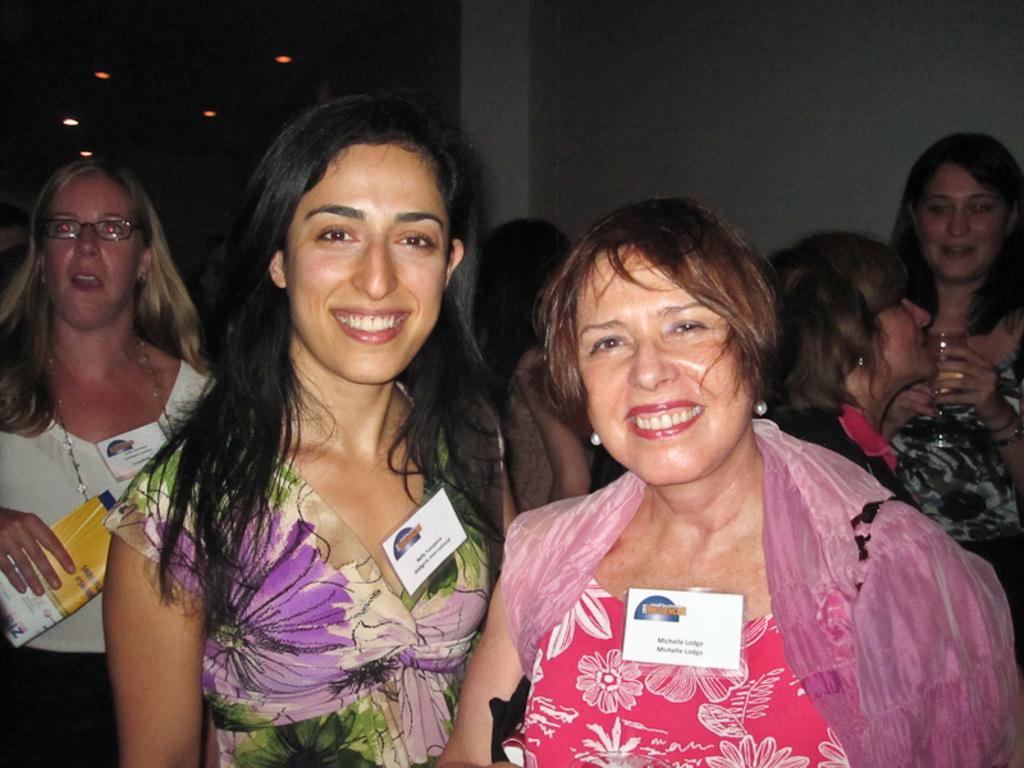In one or two sentences, can you explain what this image depicts? As we can see in the image in the front there are group of women standing and there is wall. The image is little dark. 